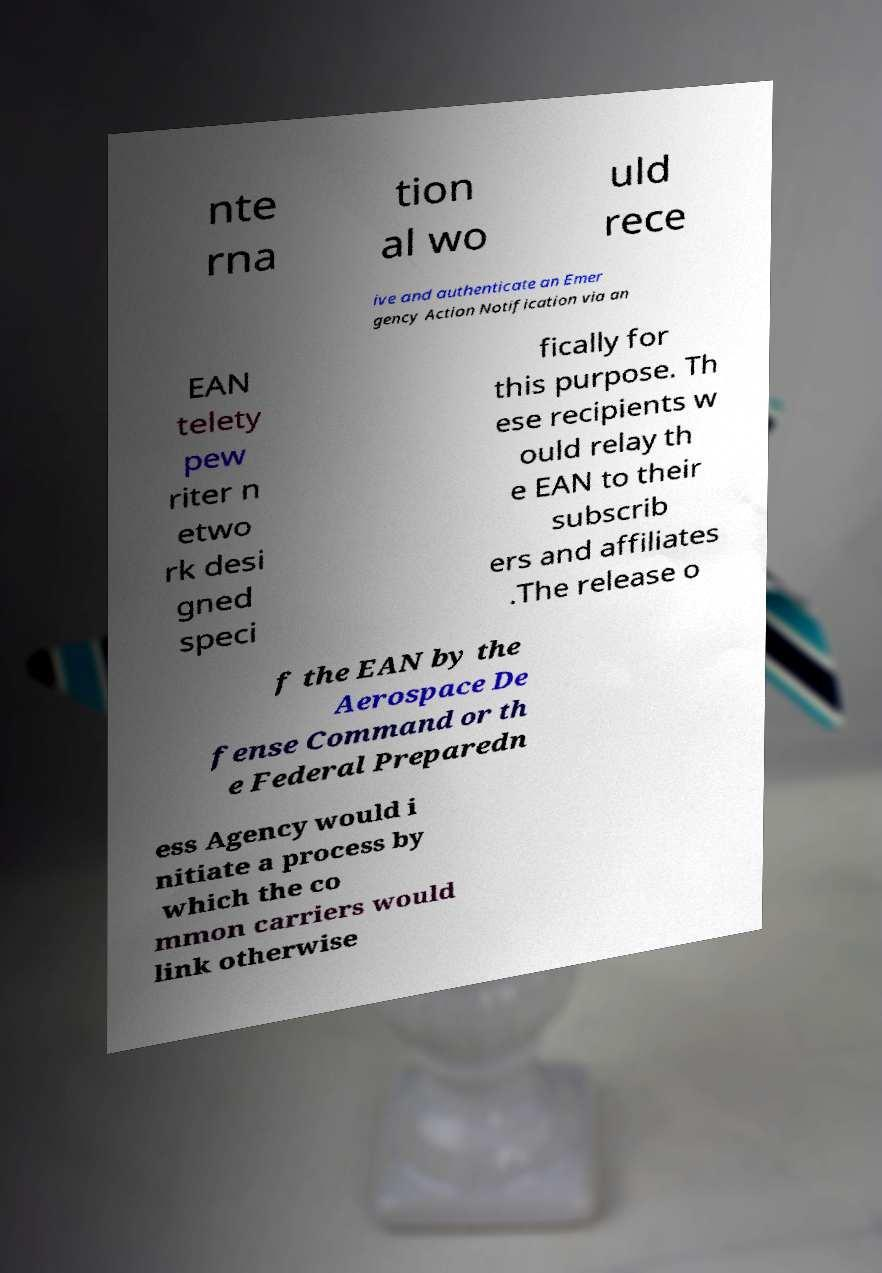Could you assist in decoding the text presented in this image and type it out clearly? nte rna tion al wo uld rece ive and authenticate an Emer gency Action Notification via an EAN telety pew riter n etwo rk desi gned speci fically for this purpose. Th ese recipients w ould relay th e EAN to their subscrib ers and affiliates .The release o f the EAN by the Aerospace De fense Command or th e Federal Preparedn ess Agency would i nitiate a process by which the co mmon carriers would link otherwise 